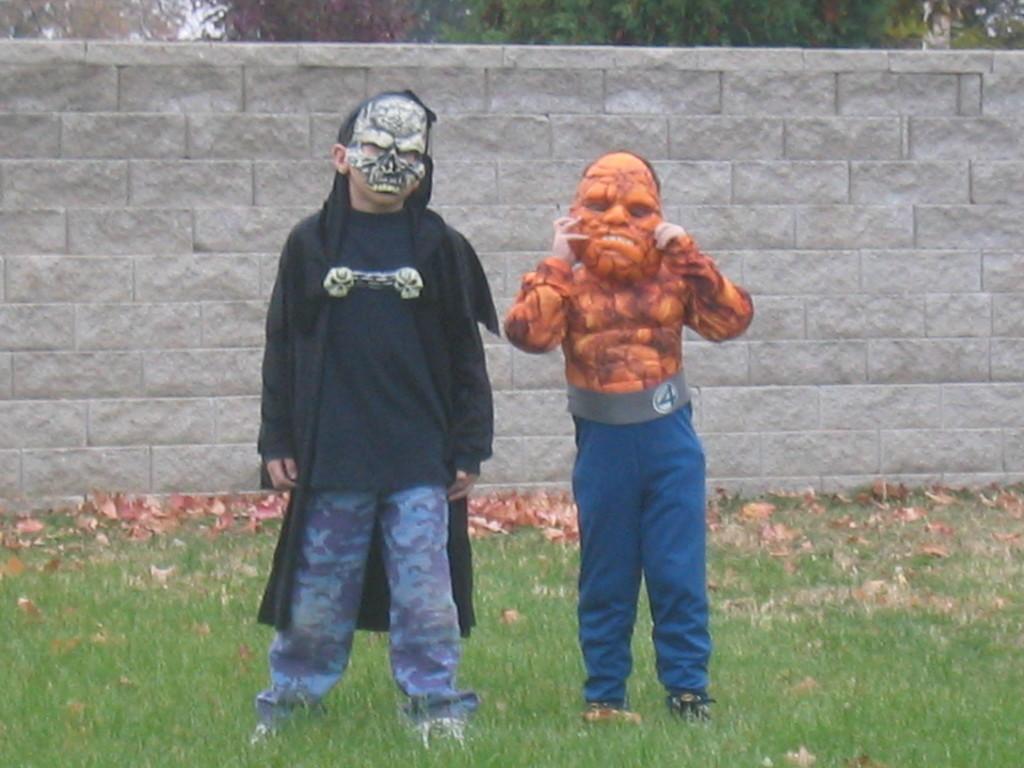In one or two sentences, can you explain what this image depicts? In this image we can see few people wearing costumes. There are many leaves on the ground. There is a grassy land in the image. There are many trees at the top of the image. There is a wall fencing in the image. 